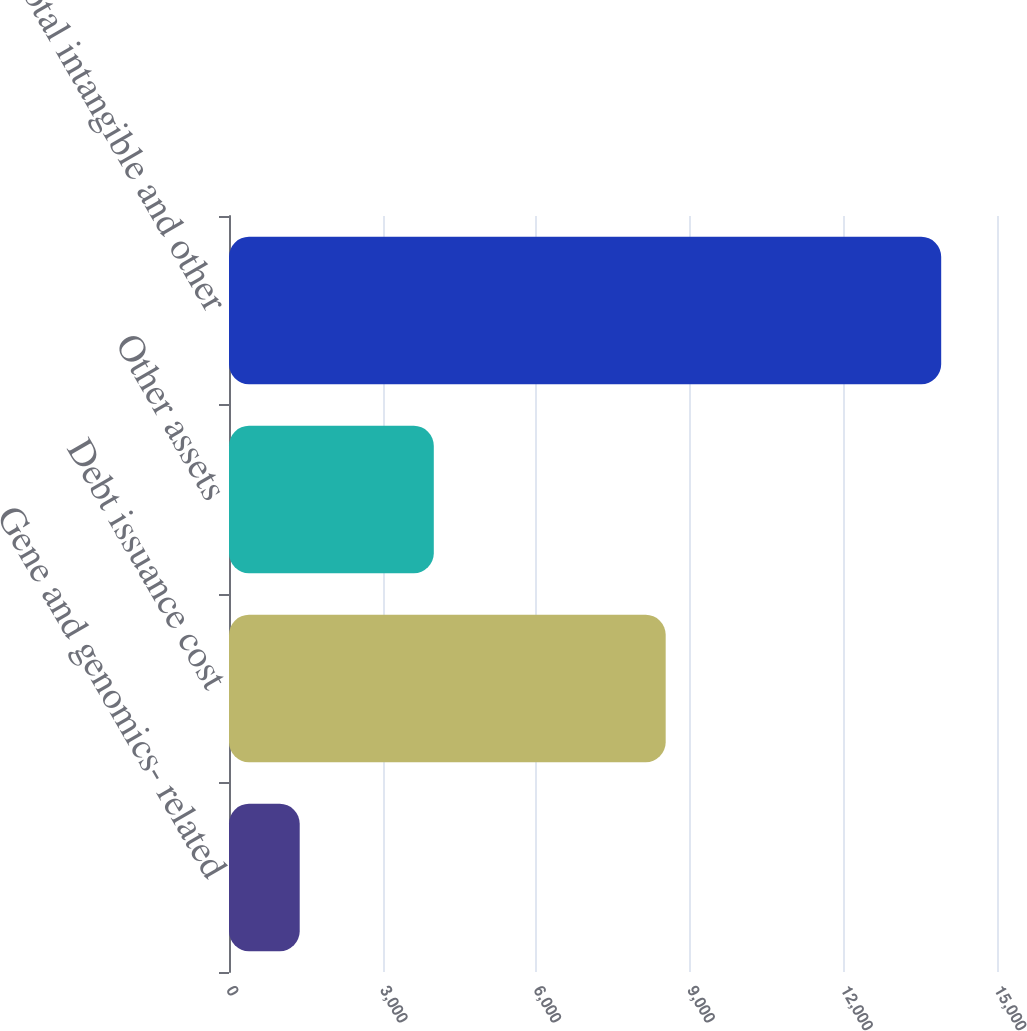Convert chart to OTSL. <chart><loc_0><loc_0><loc_500><loc_500><bar_chart><fcel>Gene and genomics- related<fcel>Debt issuance cost<fcel>Other assets<fcel>Total intangible and other<nl><fcel>1381<fcel>8529<fcel>4000<fcel>13910<nl></chart> 